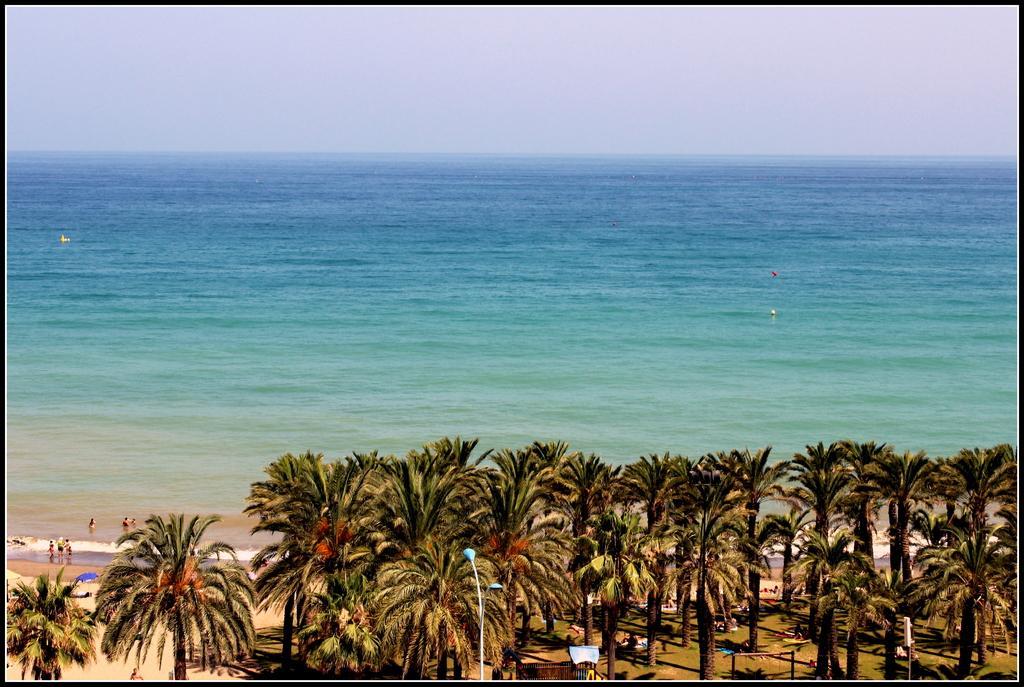Could you give a brief overview of what you see in this image? In this image I can see a pole, trees and a board on the right. There are people and water at the back. 